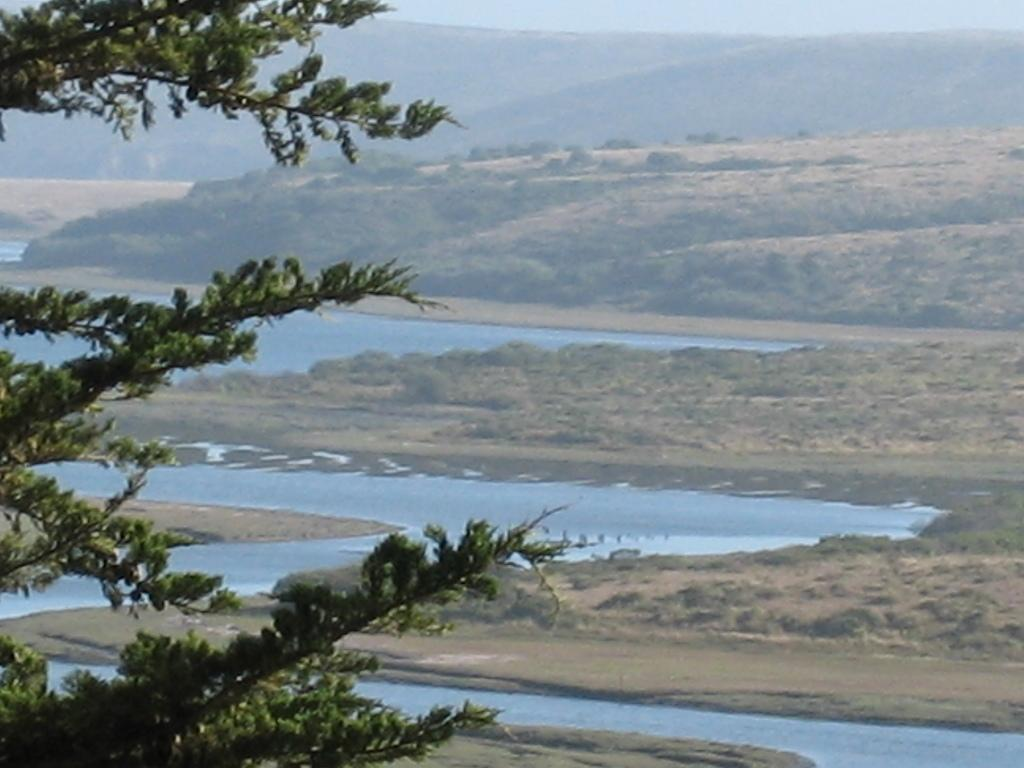What is the main object or feature in the image? There is a tree in the image. What can be seen near the tree? There is water visible in the image. What is visible in the background of the image? There are trees and mountains in the background of the image, as well as the sky. What type of line can be seen connecting the tree to the mountains in the image? There is no line connecting the tree to the mountains in the image. 